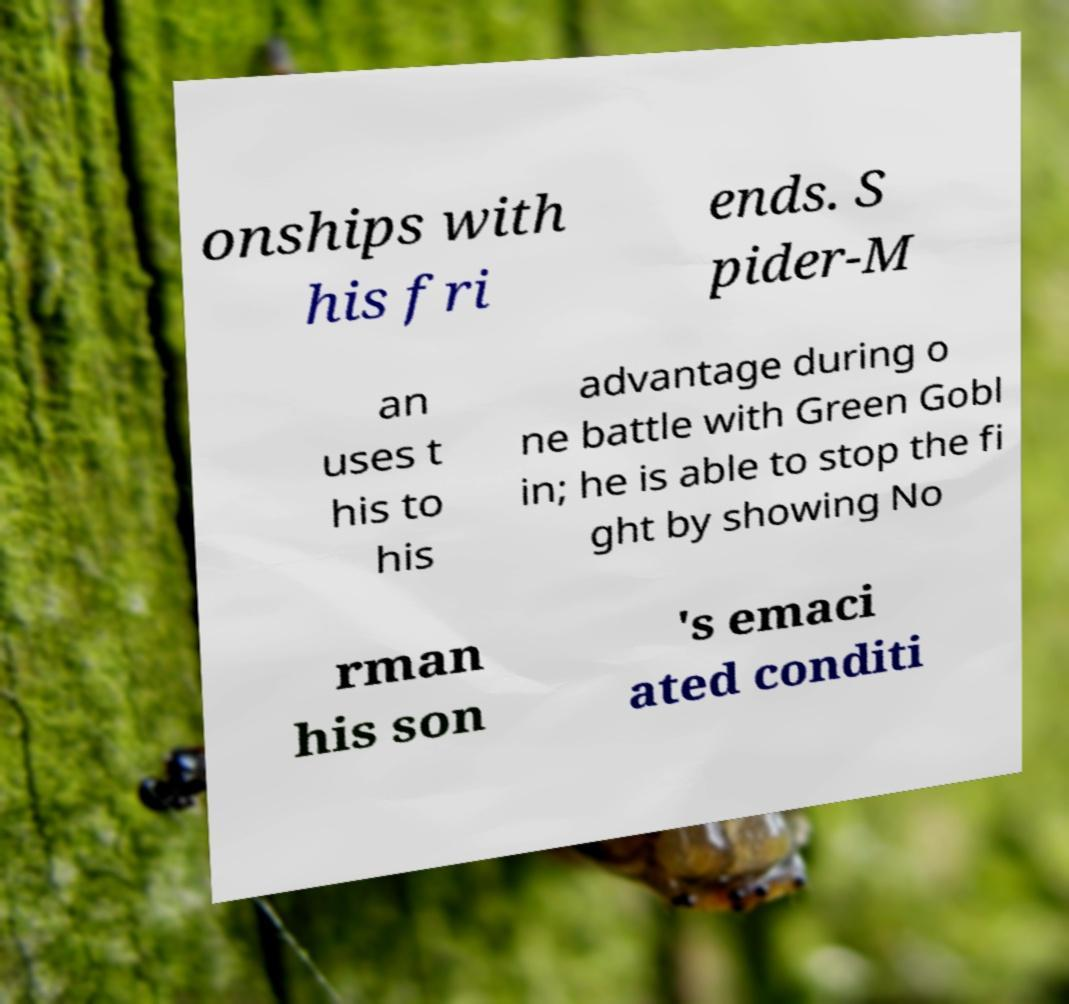For documentation purposes, I need the text within this image transcribed. Could you provide that? onships with his fri ends. S pider-M an uses t his to his advantage during o ne battle with Green Gobl in; he is able to stop the fi ght by showing No rman his son 's emaci ated conditi 